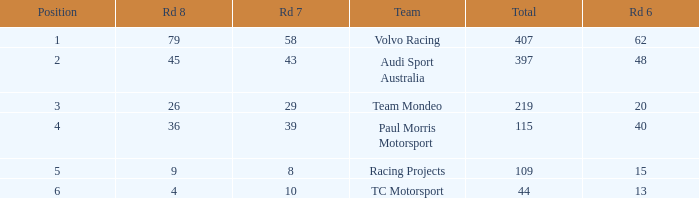What is the average value for Rd 8 in a position less than 2 for Audi Sport Australia? None. 